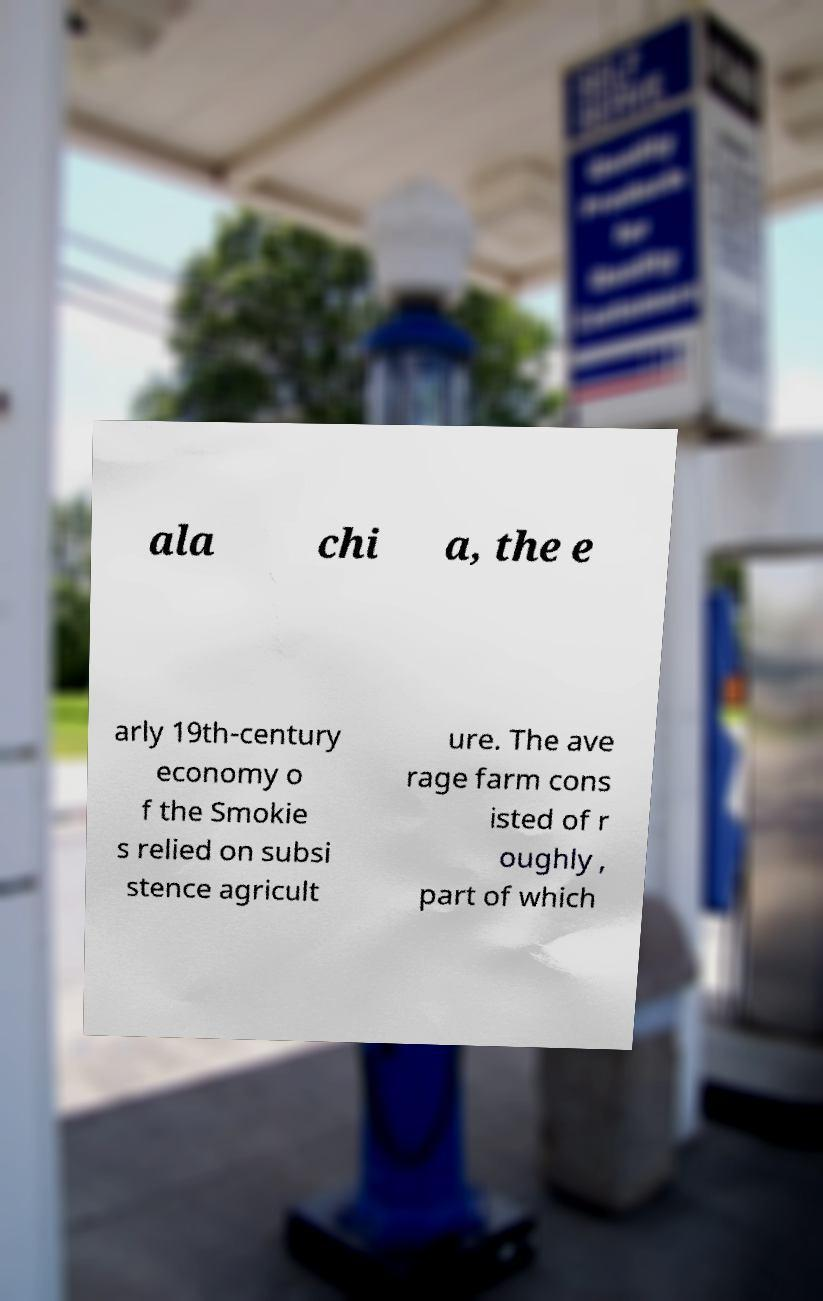For documentation purposes, I need the text within this image transcribed. Could you provide that? ala chi a, the e arly 19th-century economy o f the Smokie s relied on subsi stence agricult ure. The ave rage farm cons isted of r oughly , part of which 